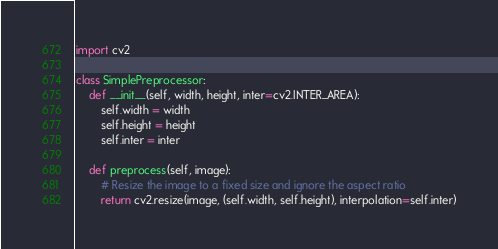Convert code to text. <code><loc_0><loc_0><loc_500><loc_500><_Python_>import cv2

class SimplePreprocessor:
    def __init__(self, width, height, inter=cv2.INTER_AREA):
        self.width = width
        self.height = height
        self.inter = inter

    def preprocess(self, image):
        # Resize the image to a fixed size and ignore the aspect ratio
        return cv2.resize(image, (self.width, self.height), interpolation=self.inter)
</code> 